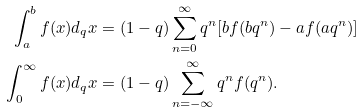<formula> <loc_0><loc_0><loc_500><loc_500>\int _ { a } ^ { b } f ( x ) d _ { q } x & = ( 1 - q ) \sum _ { n = 0 } ^ { \infty } q ^ { n } [ b f ( b q ^ { n } ) - a f ( a q ^ { n } ) ] \\ \int _ { 0 } ^ { \infty } f ( x ) d _ { q } x & = ( 1 - q ) \sum _ { n = - \infty } ^ { \infty } q ^ { n } f ( q ^ { n } ) .</formula> 